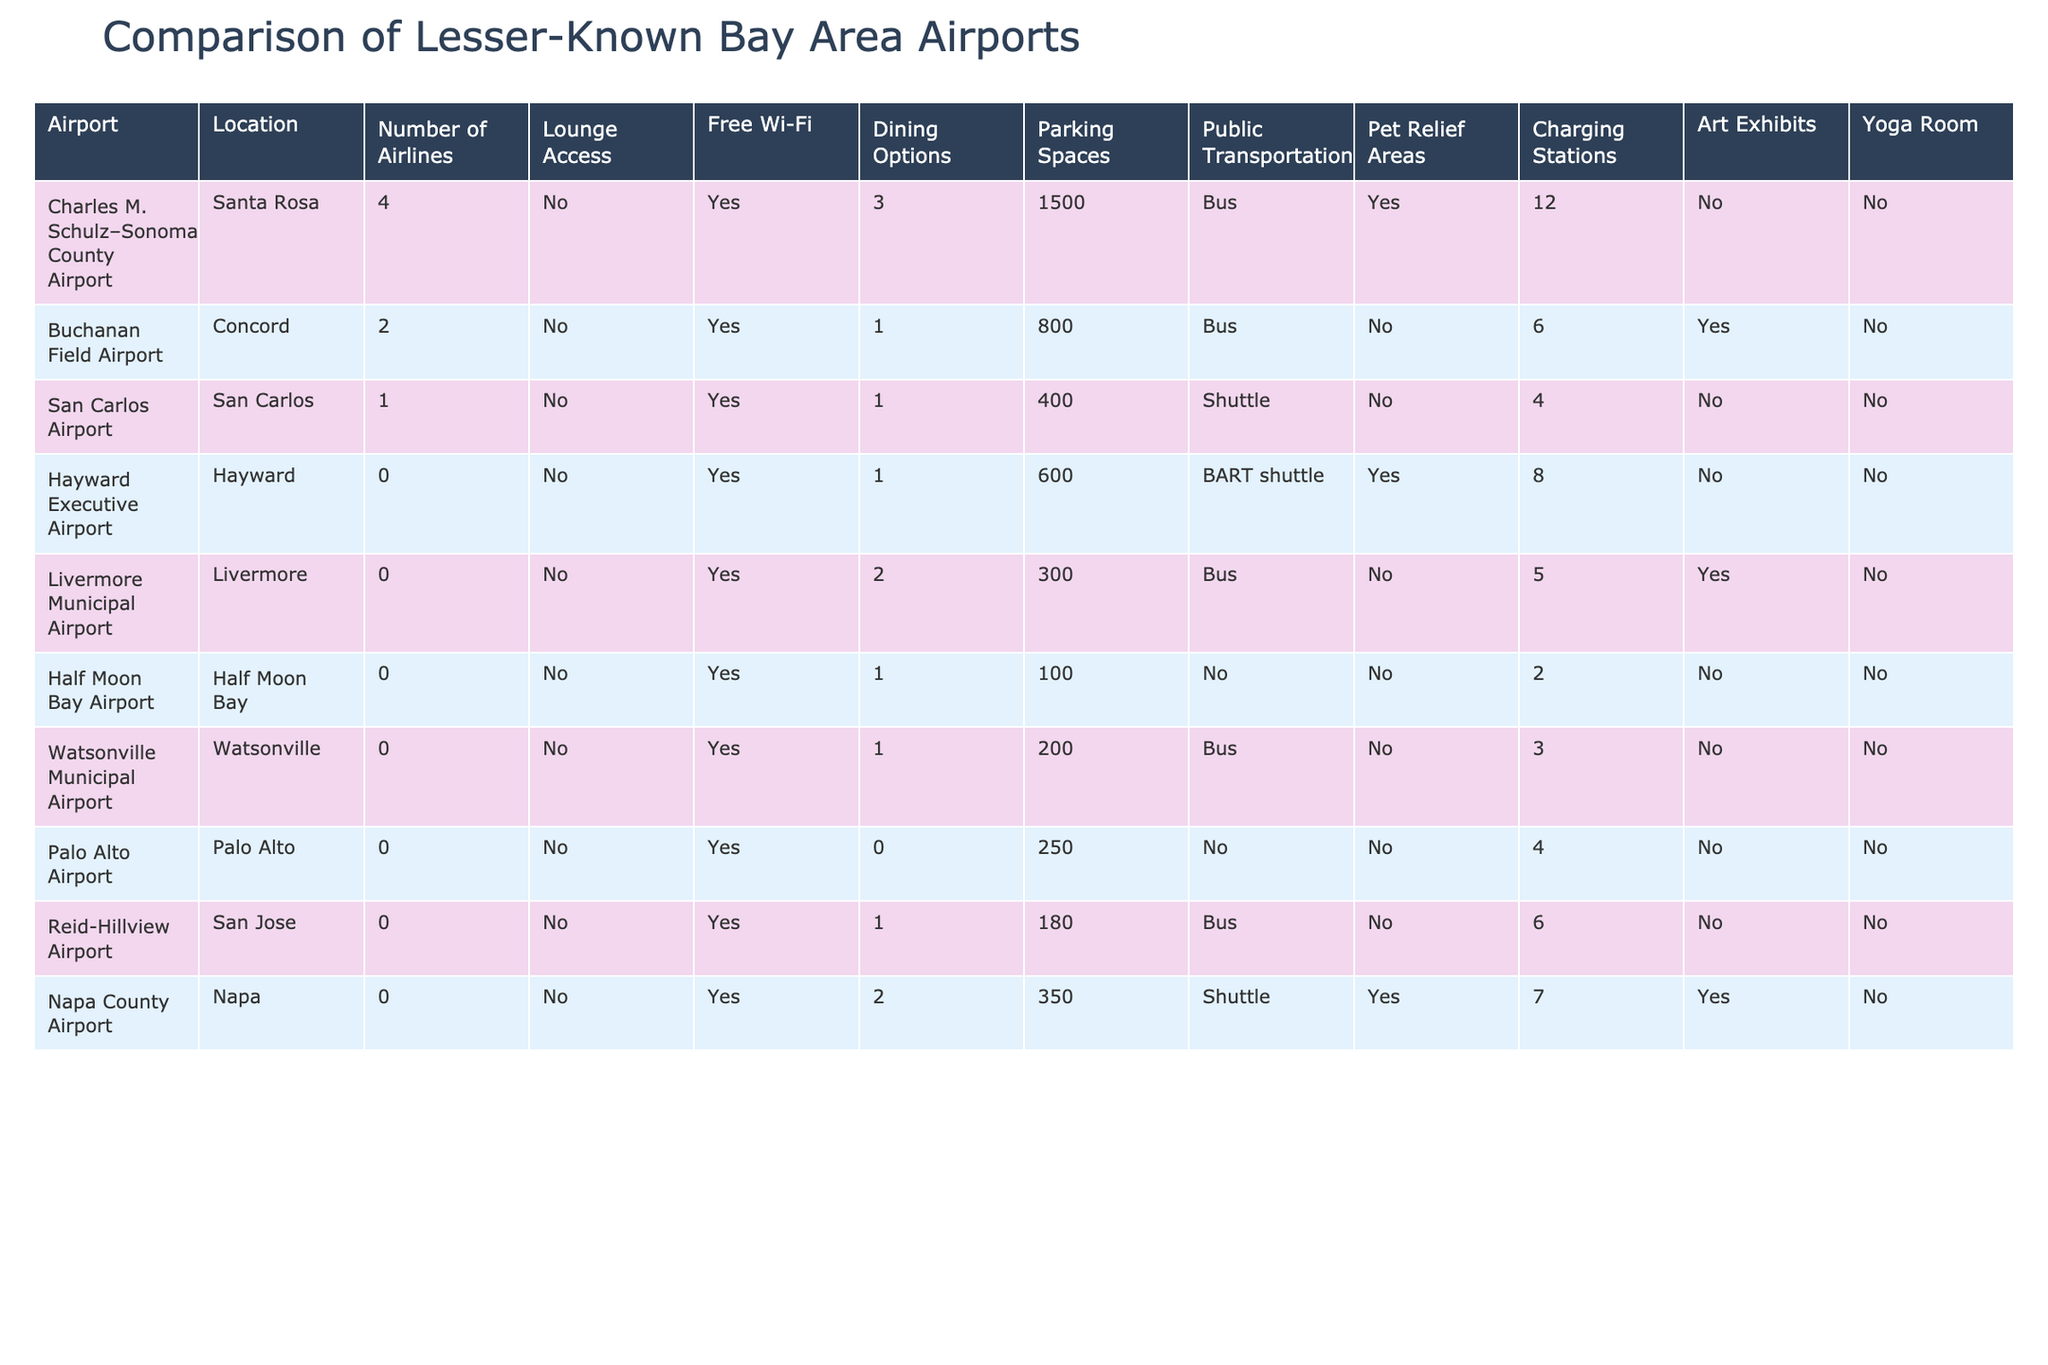What is the total number of airlines operating at the Charles M. Schulz–Sonoma County Airport? The table specifies that the Charles M. Schulz–Sonoma County Airport has 4 airlines operating. We can directly find this information in the "Number of Airlines" column for this airport.
Answer: 4 Which airport has the highest number of parking spaces? By examining the "Parking Spaces" column in the table, we can see that Charles M. Schulz–Sonoma County Airport has 1500 parking spaces, the highest among all listed airports.
Answer: 1500 Does Hayward Executive Airport offer lounge access? The table indicates that Hayward Executive Airport has "No" under the "Lounge Access" column, which means it does not offer this amenity.
Answer: No How many airports have free Wi-Fi but do not provide lounge access? We can identify the airports offering free Wi-Fi from the "Free Wi-Fi" column and then check their "Lounge Access" status. The airports with free Wi-Fi include Charles M. Schulz, Buchanan Field, San Carlos, Hayward Executive, Livermore Municipal, Half Moon Bay, Watsonville Municipal, and Reid-Hillview Airport. Out of these, all except for the Charles M. Schulz Airport and potentially others have "No" for lounge access. Counting those gives us 8 airports that provide free Wi-Fi without lounge access.
Answer: 8 What proportion of the listed airports have pet relief areas? First, we need to count the number of airports that have "Yes" under "Pet Relief Areas." From the table, only two airports (Charles M. Schulz and Napa County) have this feature, out of a total of 11 airports listed. Therefore, the proportion is 2/11, which simplifies to approximately 0.18 or 18%.
Answer: 18% Which airport has the least dining options available? By scanning the "Dining Options" column, we find that San Carlos Airport has only 1 dining option, which is the least compared to the other airports.
Answer: 1 Which airport or airports provide both art exhibits and yoga rooms? We can look for airports listed as having "Yes" under both "Art Exhibits" and "Yoga Room" columns. From the data, none of the airports offer both amenities; therefore, the answer is none.
Answer: None Which airport is served by the BART shuttle? The table shows that only Hayward Executive Airport is served by the BART shuttle, as indicated in the "Public Transportation" column.
Answer: Hayward Executive Airport What is the average number of airlines among these lesser-known Bay Area airports? To find the average, we first sum the number of airlines (4 + 2 + 1 + 0 + 0 + 0 + 0 + 0 + 0 + 0 + 0 = 7) and divide by the total number of airports (11). Therefore, the average is 7/11 which is approximately 0.636.
Answer: 0.64 